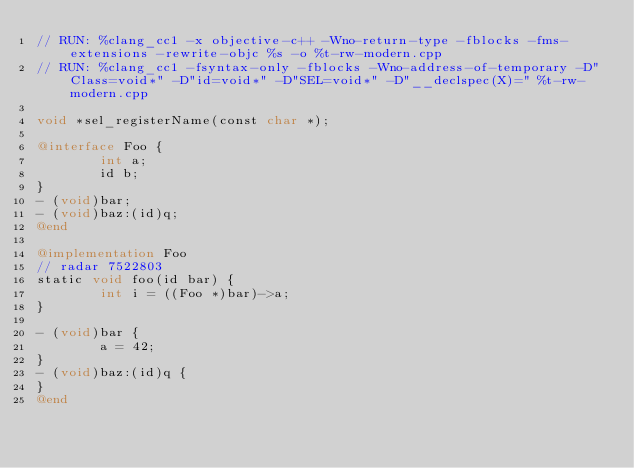<code> <loc_0><loc_0><loc_500><loc_500><_ObjectiveC_>// RUN: %clang_cc1 -x objective-c++ -Wno-return-type -fblocks -fms-extensions -rewrite-objc %s -o %t-rw-modern.cpp
// RUN: %clang_cc1 -fsyntax-only -fblocks -Wno-address-of-temporary -D"Class=void*" -D"id=void*" -D"SEL=void*" -D"__declspec(X)=" %t-rw-modern.cpp

void *sel_registerName(const char *);

@interface Foo {
        int a;
        id b;
}
- (void)bar;
- (void)baz:(id)q;
@end

@implementation Foo
// radar 7522803
static void foo(id bar) {
        int i = ((Foo *)bar)->a;
}

- (void)bar {
        a = 42;
}
- (void)baz:(id)q {
}
@end

</code> 